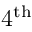<formula> <loc_0><loc_0><loc_500><loc_500>4 ^ { t h }</formula> 